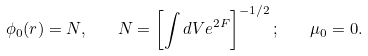Convert formula to latex. <formula><loc_0><loc_0><loc_500><loc_500>\phi _ { 0 } ( { r } ) = N , \quad N = \left [ \int d V e ^ { 2 F } \right ] ^ { - 1 / 2 } ; \quad \mu _ { 0 } = 0 .</formula> 